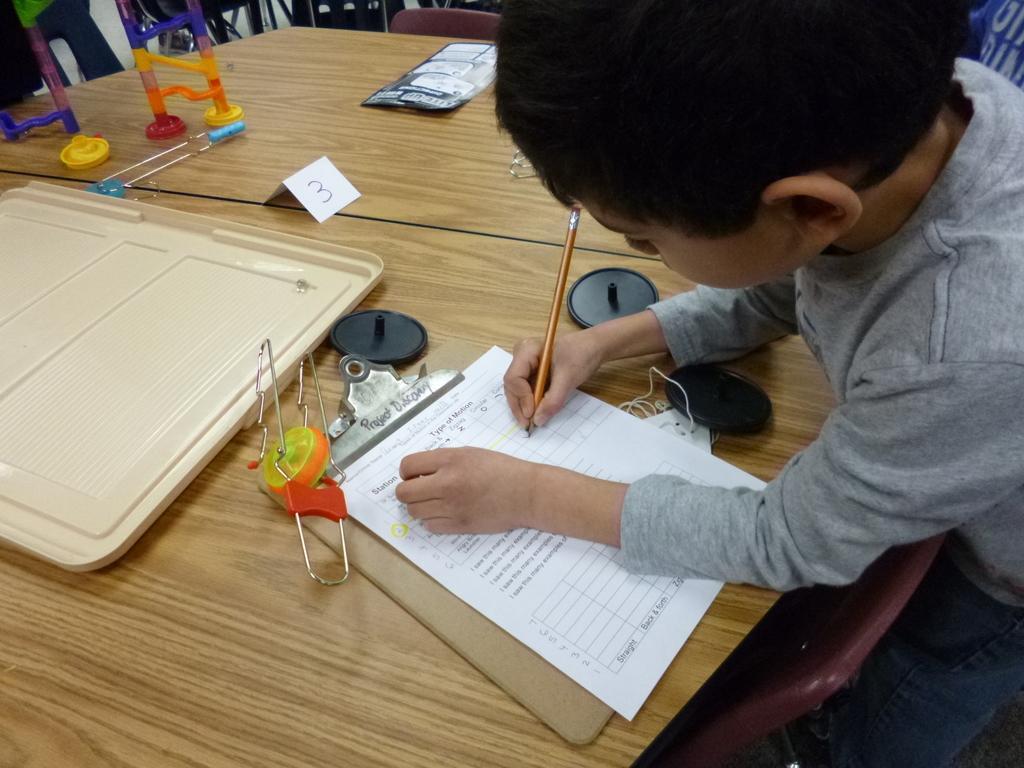Please provide a concise description of this image. In this image I can see a table , on the table I can see tray , wooden pad, paper, some toys and a boy holding a pencil visible on the right side , in front of the table there is a chair visible at the bottom. 